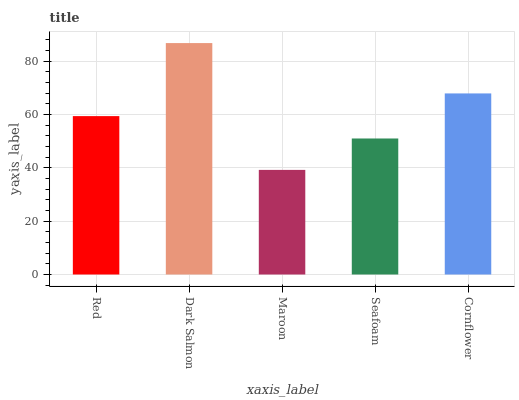Is Maroon the minimum?
Answer yes or no. Yes. Is Dark Salmon the maximum?
Answer yes or no. Yes. Is Dark Salmon the minimum?
Answer yes or no. No. Is Maroon the maximum?
Answer yes or no. No. Is Dark Salmon greater than Maroon?
Answer yes or no. Yes. Is Maroon less than Dark Salmon?
Answer yes or no. Yes. Is Maroon greater than Dark Salmon?
Answer yes or no. No. Is Dark Salmon less than Maroon?
Answer yes or no. No. Is Red the high median?
Answer yes or no. Yes. Is Red the low median?
Answer yes or no. Yes. Is Maroon the high median?
Answer yes or no. No. Is Seafoam the low median?
Answer yes or no. No. 